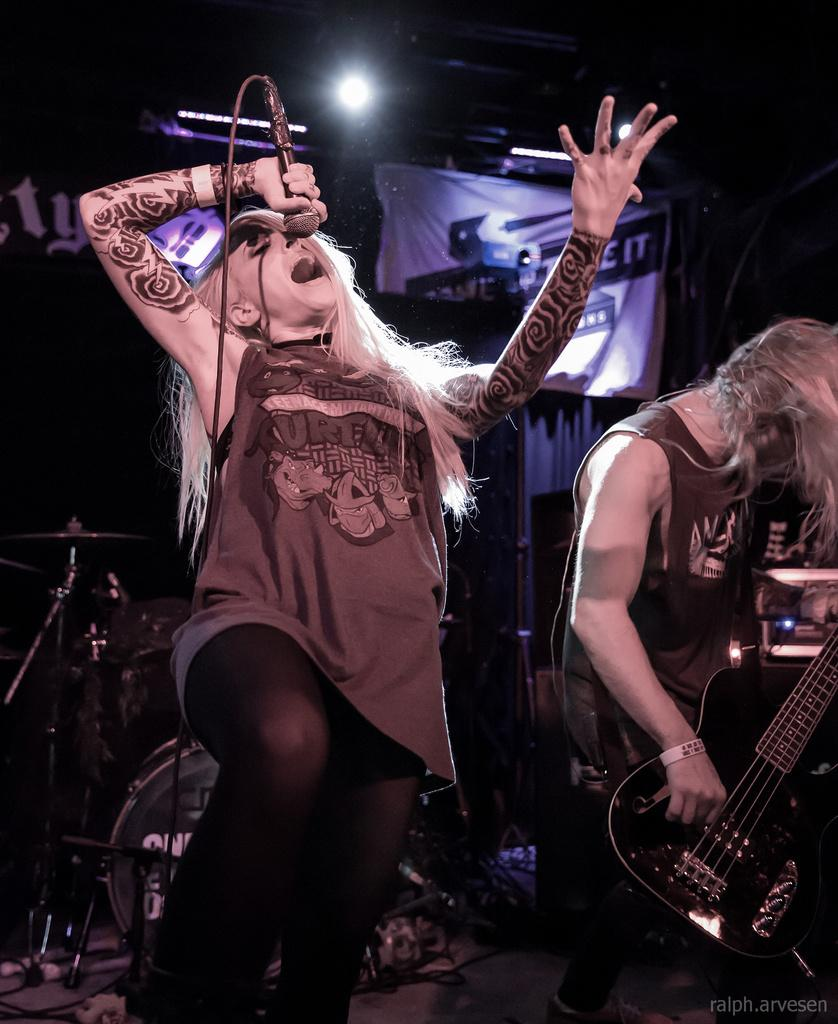How many people are in the image? There are two persons in the image. Where are the persons located in the image? Both persons are standing on a stage. What is the person on the right side holding? The person on the right side is holding a guitar. What is the person on the left side doing? The person on the left side is singing a song. What type of market is visible in the background of the image? There is no market visible in the background of the image. How many sons does the person on the left side have? The provided facts do not mention any sons, so it cannot be determined from the image. 